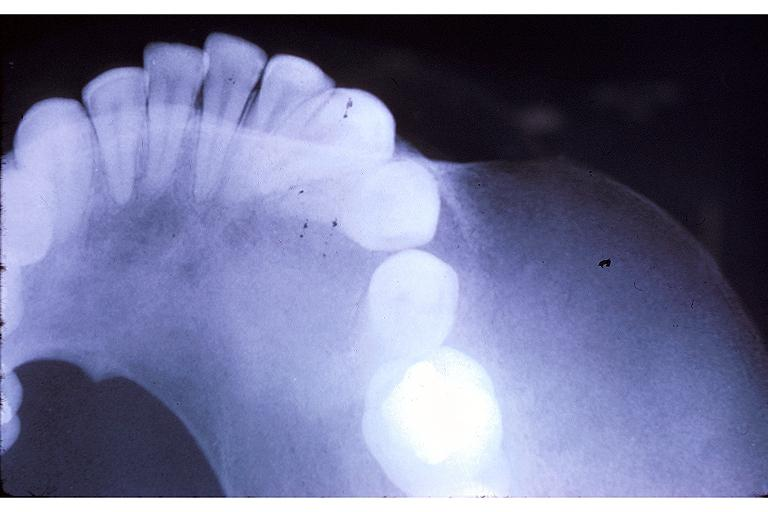s close-up view present?
Answer the question using a single word or phrase. No 